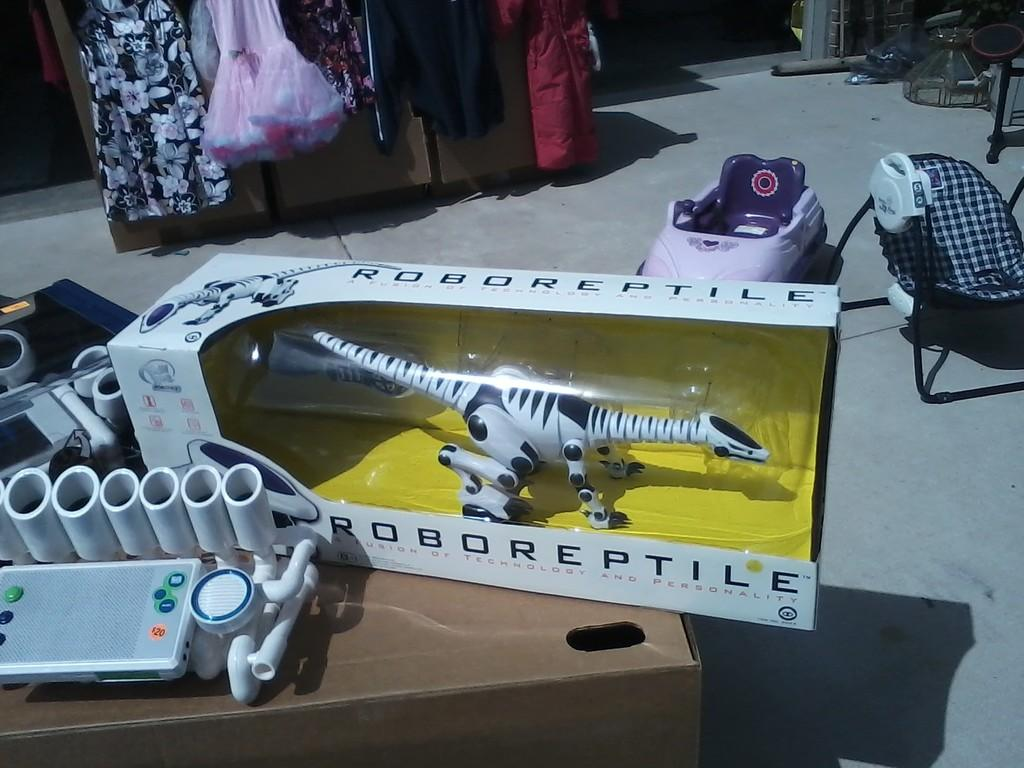Provide a one-sentence caption for the provided image. a cluttered room with a RoboReptile in a box. 